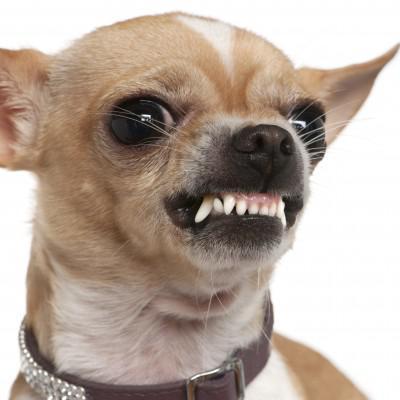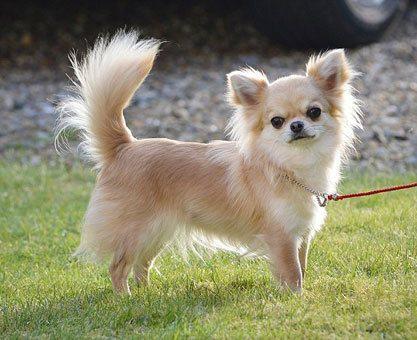The first image is the image on the left, the second image is the image on the right. Examine the images to the left and right. Is the description "There is a background in the image to the right." accurate? Answer yes or no. Yes. 